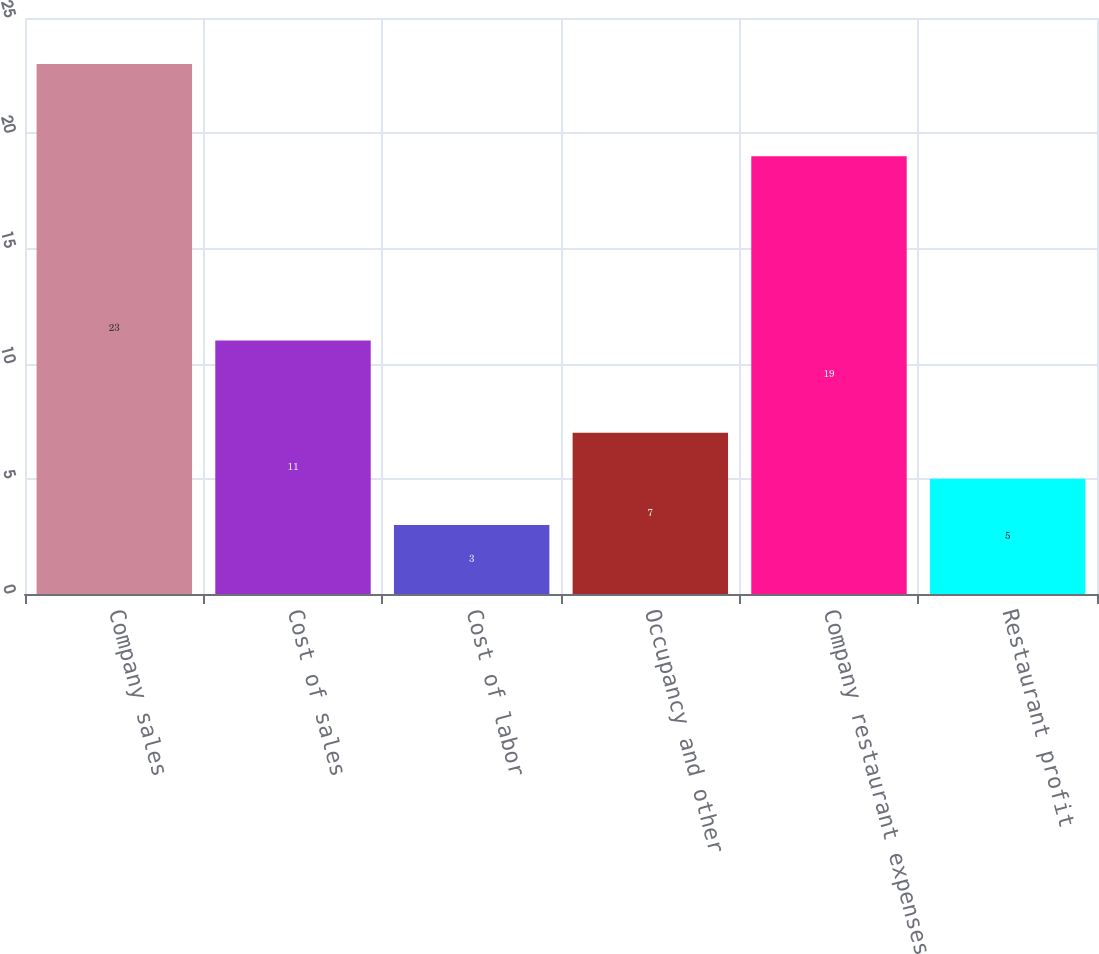Convert chart to OTSL. <chart><loc_0><loc_0><loc_500><loc_500><bar_chart><fcel>Company sales<fcel>Cost of sales<fcel>Cost of labor<fcel>Occupancy and other<fcel>Company restaurant expenses<fcel>Restaurant profit<nl><fcel>23<fcel>11<fcel>3<fcel>7<fcel>19<fcel>5<nl></chart> 